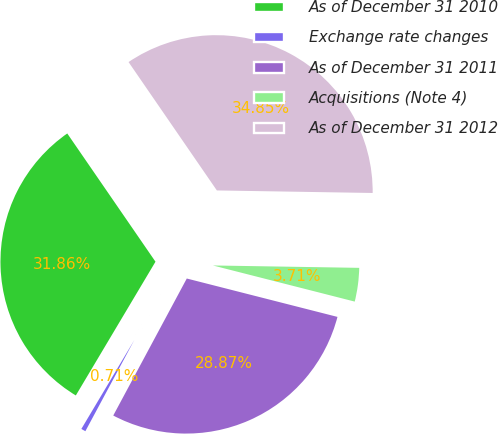Convert chart to OTSL. <chart><loc_0><loc_0><loc_500><loc_500><pie_chart><fcel>As of December 31 2010<fcel>Exchange rate changes<fcel>As of December 31 2011<fcel>Acquisitions (Note 4)<fcel>As of December 31 2012<nl><fcel>31.86%<fcel>0.71%<fcel>28.87%<fcel>3.71%<fcel>34.85%<nl></chart> 